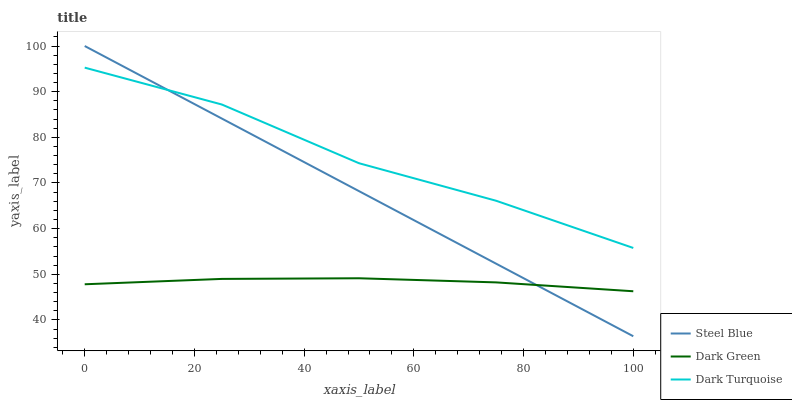Does Dark Green have the minimum area under the curve?
Answer yes or no. Yes. Does Dark Turquoise have the maximum area under the curve?
Answer yes or no. Yes. Does Steel Blue have the minimum area under the curve?
Answer yes or no. No. Does Steel Blue have the maximum area under the curve?
Answer yes or no. No. Is Steel Blue the smoothest?
Answer yes or no. Yes. Is Dark Turquoise the roughest?
Answer yes or no. Yes. Is Dark Green the smoothest?
Answer yes or no. No. Is Dark Green the roughest?
Answer yes or no. No. Does Steel Blue have the lowest value?
Answer yes or no. Yes. Does Dark Green have the lowest value?
Answer yes or no. No. Does Steel Blue have the highest value?
Answer yes or no. Yes. Does Dark Green have the highest value?
Answer yes or no. No. Is Dark Green less than Dark Turquoise?
Answer yes or no. Yes. Is Dark Turquoise greater than Dark Green?
Answer yes or no. Yes. Does Steel Blue intersect Dark Green?
Answer yes or no. Yes. Is Steel Blue less than Dark Green?
Answer yes or no. No. Is Steel Blue greater than Dark Green?
Answer yes or no. No. Does Dark Green intersect Dark Turquoise?
Answer yes or no. No. 